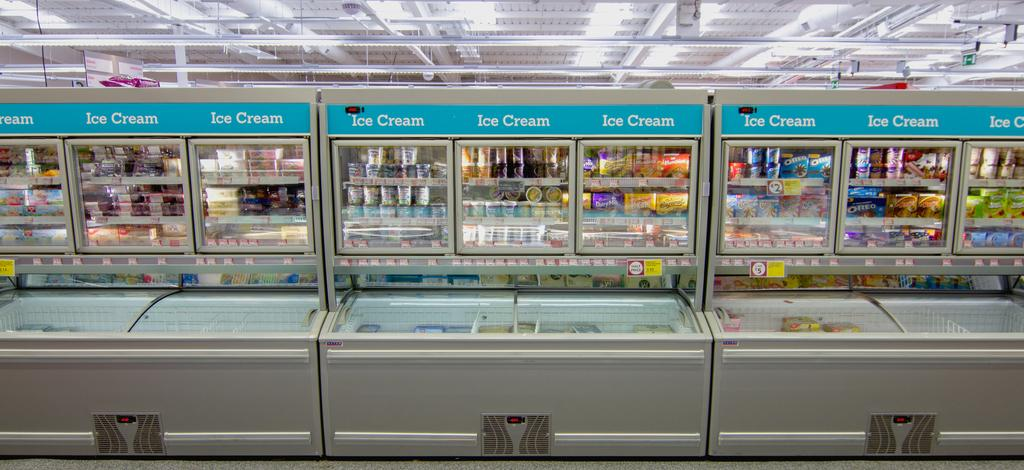<image>
Create a compact narrative representing the image presented. Freezer section of a grocery store with Ice Cream written on the top of the coolers. 